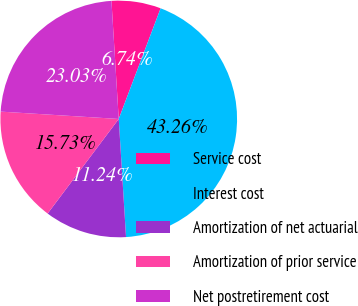Convert chart. <chart><loc_0><loc_0><loc_500><loc_500><pie_chart><fcel>Service cost<fcel>Interest cost<fcel>Amortization of net actuarial<fcel>Amortization of prior service<fcel>Net postretirement cost<nl><fcel>6.74%<fcel>43.26%<fcel>11.24%<fcel>15.73%<fcel>23.03%<nl></chart> 